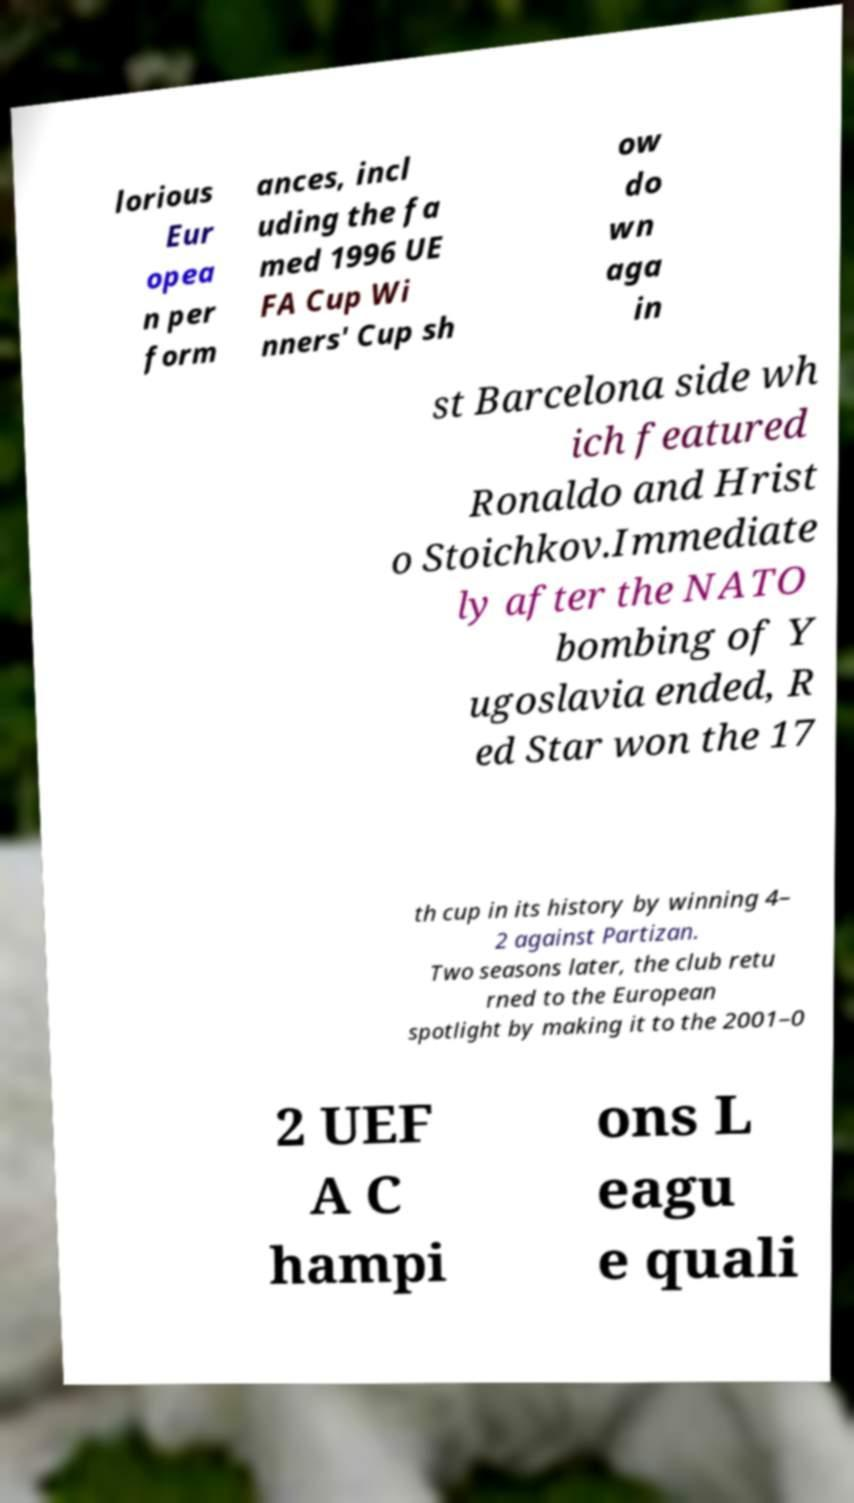For documentation purposes, I need the text within this image transcribed. Could you provide that? lorious Eur opea n per form ances, incl uding the fa med 1996 UE FA Cup Wi nners' Cup sh ow do wn aga in st Barcelona side wh ich featured Ronaldo and Hrist o Stoichkov.Immediate ly after the NATO bombing of Y ugoslavia ended, R ed Star won the 17 th cup in its history by winning 4– 2 against Partizan. Two seasons later, the club retu rned to the European spotlight by making it to the 2001–0 2 UEF A C hampi ons L eagu e quali 